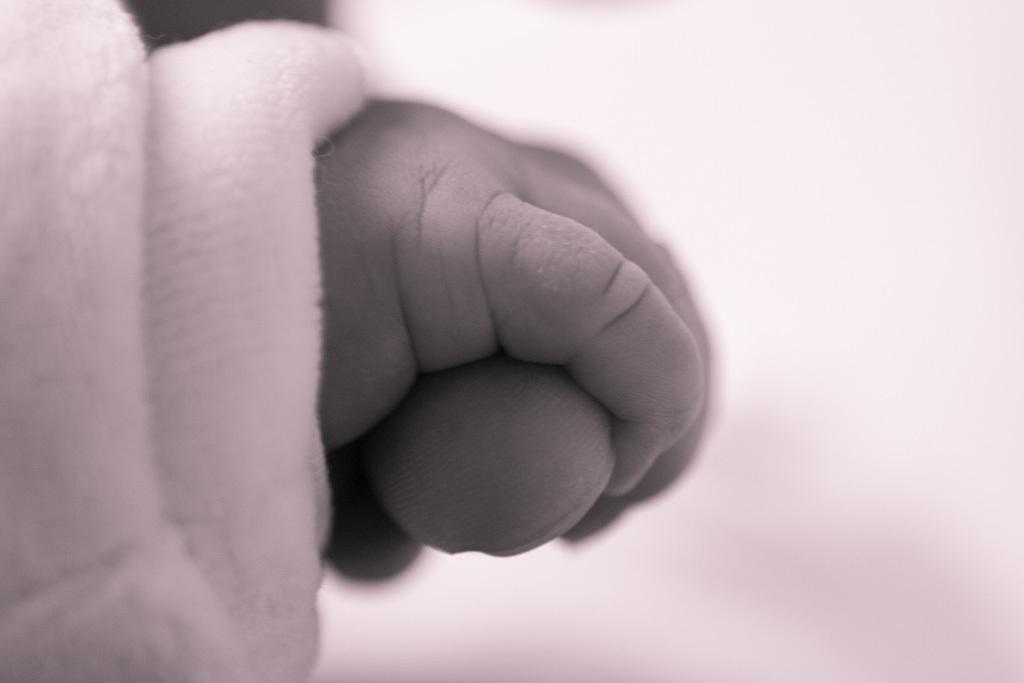What is the color scheme of the image? The image is black and white. What can be seen in the image involving a baby and an adult? A baby's hand is holding an adult finger. What is the adult wearing in the image? The adult is wearing a white color dress. What direction is the baby facing in the image? The direction the baby is facing cannot be determined from the image, as it is a black and white image and does not provide any context for the baby's orientation. 